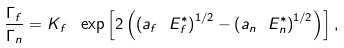<formula> <loc_0><loc_0><loc_500><loc_500>\frac { \Gamma _ { f } } { \Gamma _ { n } } = K _ { f } \text { } \exp \left [ 2 \left ( \left ( a _ { f } \ E _ { f } ^ { \ast } \right ) ^ { 1 / 2 } - \left ( a _ { n } \ E _ { n } ^ { \ast } \right ) ^ { 1 / 2 } \right ) \right ] ,</formula> 